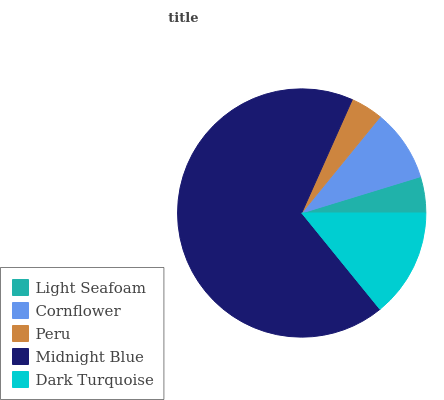Is Peru the minimum?
Answer yes or no. Yes. Is Midnight Blue the maximum?
Answer yes or no. Yes. Is Cornflower the minimum?
Answer yes or no. No. Is Cornflower the maximum?
Answer yes or no. No. Is Cornflower greater than Light Seafoam?
Answer yes or no. Yes. Is Light Seafoam less than Cornflower?
Answer yes or no. Yes. Is Light Seafoam greater than Cornflower?
Answer yes or no. No. Is Cornflower less than Light Seafoam?
Answer yes or no. No. Is Cornflower the high median?
Answer yes or no. Yes. Is Cornflower the low median?
Answer yes or no. Yes. Is Peru the high median?
Answer yes or no. No. Is Midnight Blue the low median?
Answer yes or no. No. 